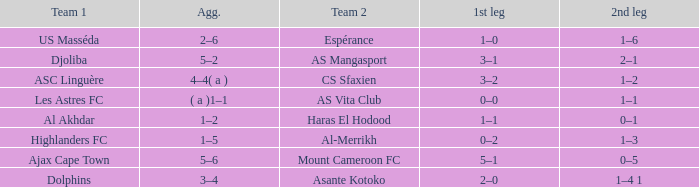What is the team 1 with team 2 Mount Cameroon FC? Ajax Cape Town. 